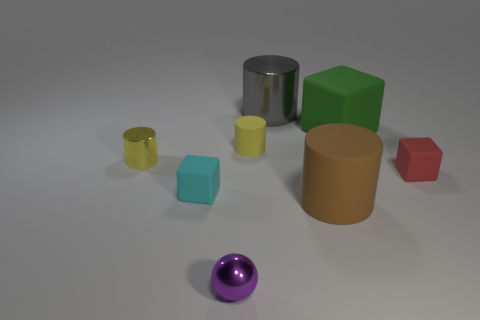The metallic ball is what size?
Give a very brief answer. Small. What shape is the metallic thing that is both right of the cyan block and behind the big brown object?
Make the answer very short. Cylinder. What number of brown objects are cubes or metallic cylinders?
Provide a short and direct response. 0. There is a cylinder in front of the small red rubber thing; is its size the same as the yellow thing that is to the right of the tiny cyan rubber thing?
Make the answer very short. No. What number of objects are tiny red rubber objects or large cylinders?
Your answer should be very brief. 3. Is there a cyan rubber thing of the same shape as the small purple object?
Provide a short and direct response. No. Is the number of matte cylinders less than the number of big cyan matte spheres?
Your answer should be very brief. No. Does the large green thing have the same shape as the cyan rubber thing?
Your answer should be very brief. Yes. What number of objects are small brown cubes or things on the right side of the large brown matte cylinder?
Your answer should be compact. 2. How many small cyan rubber balls are there?
Provide a short and direct response. 0. 